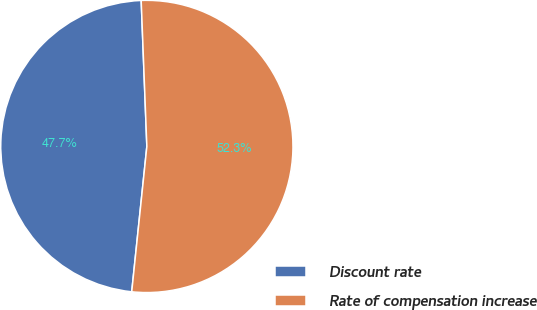Convert chart. <chart><loc_0><loc_0><loc_500><loc_500><pie_chart><fcel>Discount rate<fcel>Rate of compensation increase<nl><fcel>47.73%<fcel>52.27%<nl></chart> 